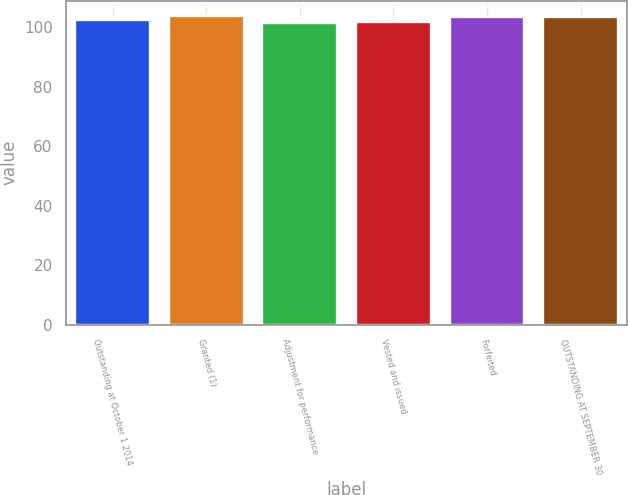Convert chart to OTSL. <chart><loc_0><loc_0><loc_500><loc_500><bar_chart><fcel>Outstanding at October 1 2014<fcel>Granted (1)<fcel>Adjustment for performance<fcel>Vested and issued<fcel>Forfeited<fcel>OUTSTANDING AT SEPTEMBER 30<nl><fcel>102.54<fcel>103.77<fcel>101.57<fcel>101.78<fcel>103.56<fcel>103.33<nl></chart> 